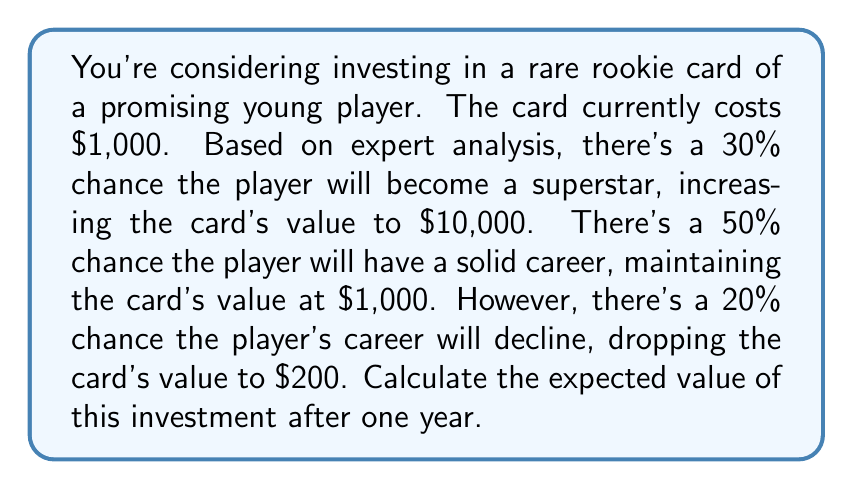Help me with this question. To calculate the expected value of this investment, we need to use the formula for expected value:

$$ E(X) = \sum_{i=1}^{n} p_i \cdot x_i $$

Where:
$E(X)$ is the expected value
$p_i$ is the probability of each outcome
$x_i$ is the value associated with each outcome

Let's break down the given information:

1. Superstar scenario: 
   Probability $p_1 = 0.30$, Value $x_1 = \$10,000$

2. Solid career scenario:
   Probability $p_2 = 0.50$, Value $x_2 = \$1,000$

3. Career decline scenario:
   Probability $p_3 = 0.20$, Value $x_3 = \$200$

Now, let's apply the formula:

$$ E(X) = (0.30 \cdot \$10,000) + (0.50 \cdot \$1,000) + (0.20 \cdot \$200) $$

$$ E(X) = \$3,000 + \$500 + \$40 $$

$$ E(X) = \$3,540 $$

This means that the expected value of the investment after one year is $3,540.

To calculate the expected return on investment (ROI), we can use:

$$ \text{Expected ROI} = \frac{\text{Expected Value} - \text{Initial Investment}}{\text{Initial Investment}} \times 100\% $$

$$ \text{Expected ROI} = \frac{\$3,540 - \$1,000}{\$1,000} \times 100\% = 254\% $$
Answer: The expected value of the rare rookie card investment after one year is $3,540, with an expected return on investment of 254%. 